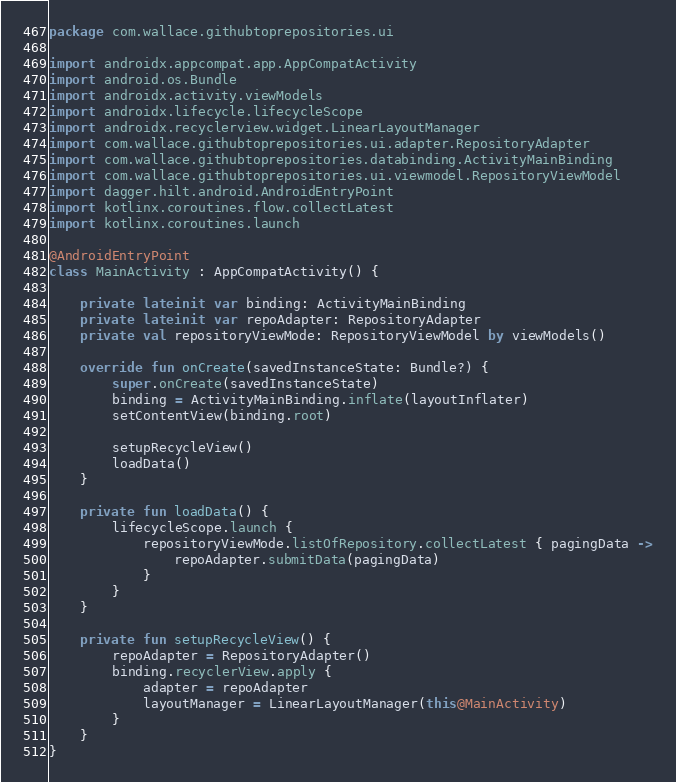Convert code to text. <code><loc_0><loc_0><loc_500><loc_500><_Kotlin_>package com.wallace.githubtoprepositories.ui

import androidx.appcompat.app.AppCompatActivity
import android.os.Bundle
import androidx.activity.viewModels
import androidx.lifecycle.lifecycleScope
import androidx.recyclerview.widget.LinearLayoutManager
import com.wallace.githubtoprepositories.ui.adapter.RepositoryAdapter
import com.wallace.githubtoprepositories.databinding.ActivityMainBinding
import com.wallace.githubtoprepositories.ui.viewmodel.RepositoryViewModel
import dagger.hilt.android.AndroidEntryPoint
import kotlinx.coroutines.flow.collectLatest
import kotlinx.coroutines.launch

@AndroidEntryPoint
class MainActivity : AppCompatActivity() {

    private lateinit var binding: ActivityMainBinding
    private lateinit var repoAdapter: RepositoryAdapter
    private val repositoryViewMode: RepositoryViewModel by viewModels()

    override fun onCreate(savedInstanceState: Bundle?) {
        super.onCreate(savedInstanceState)
        binding = ActivityMainBinding.inflate(layoutInflater)
        setContentView(binding.root)

        setupRecycleView()
        loadData()
    }

    private fun loadData() {
        lifecycleScope.launch {
            repositoryViewMode.listOfRepository.collectLatest { pagingData ->
                repoAdapter.submitData(pagingData)
            }
        }
    }

    private fun setupRecycleView() {
        repoAdapter = RepositoryAdapter()
        binding.recyclerView.apply {
            adapter = repoAdapter
            layoutManager = LinearLayoutManager(this@MainActivity)
        }
    }
}</code> 